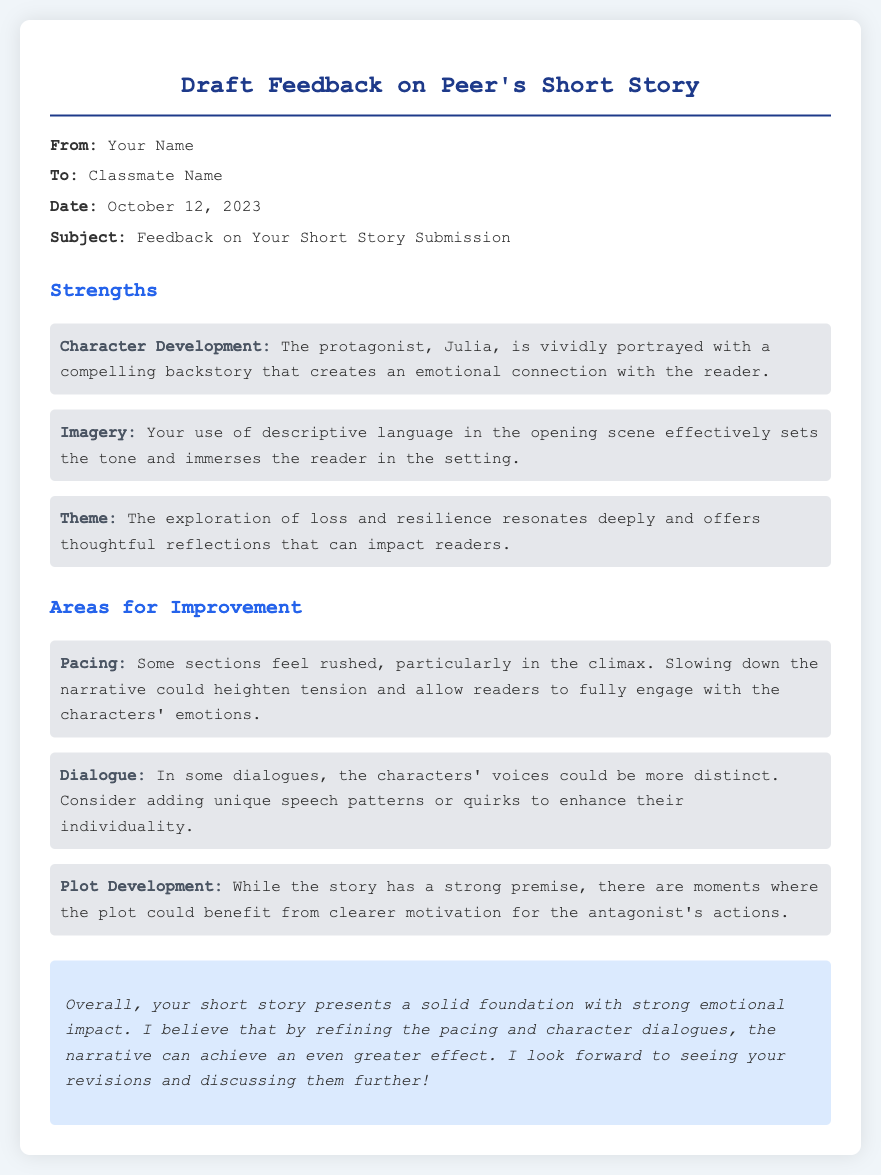What is the title of the memo? The title of the memo is the main heading at the top of the document.
Answer: Draft Feedback on Peer's Short Story Who is the feedback directed to? The "To" section of the header specifies the recipient of the feedback.
Answer: Classmate Name What date was the feedback given? The "Date" section in the header provides the date the feedback was written.
Answer: October 12, 2023 What is one strength mentioned about character development? The strengths section includes specific aspects of character portrayal relating to the protagonist.
Answer: Compelling backstory What aspect of imagery is highlighted? The memo includes a specific point about the use of descriptive language.
Answer: Sets the tone What is noted as an area for improvement related to pacing? The areas for improvement section discusses specific sections of the story that need attention.
Answer: Some sections feel rushed What does the memo suggest to enhance dialogue? The feedback mentions how character voices can be improved through specific techniques.
Answer: Unique speech patterns What theme is explored in the short story? The strengths section mentions a significant theme that resonates with readers.
Answer: Loss and resilience What suggestion is made regarding plot development? The areas for improvement provide a recommendation concerning antagonist motivations.
Answer: Clearer motivation for the antagonist's actions 